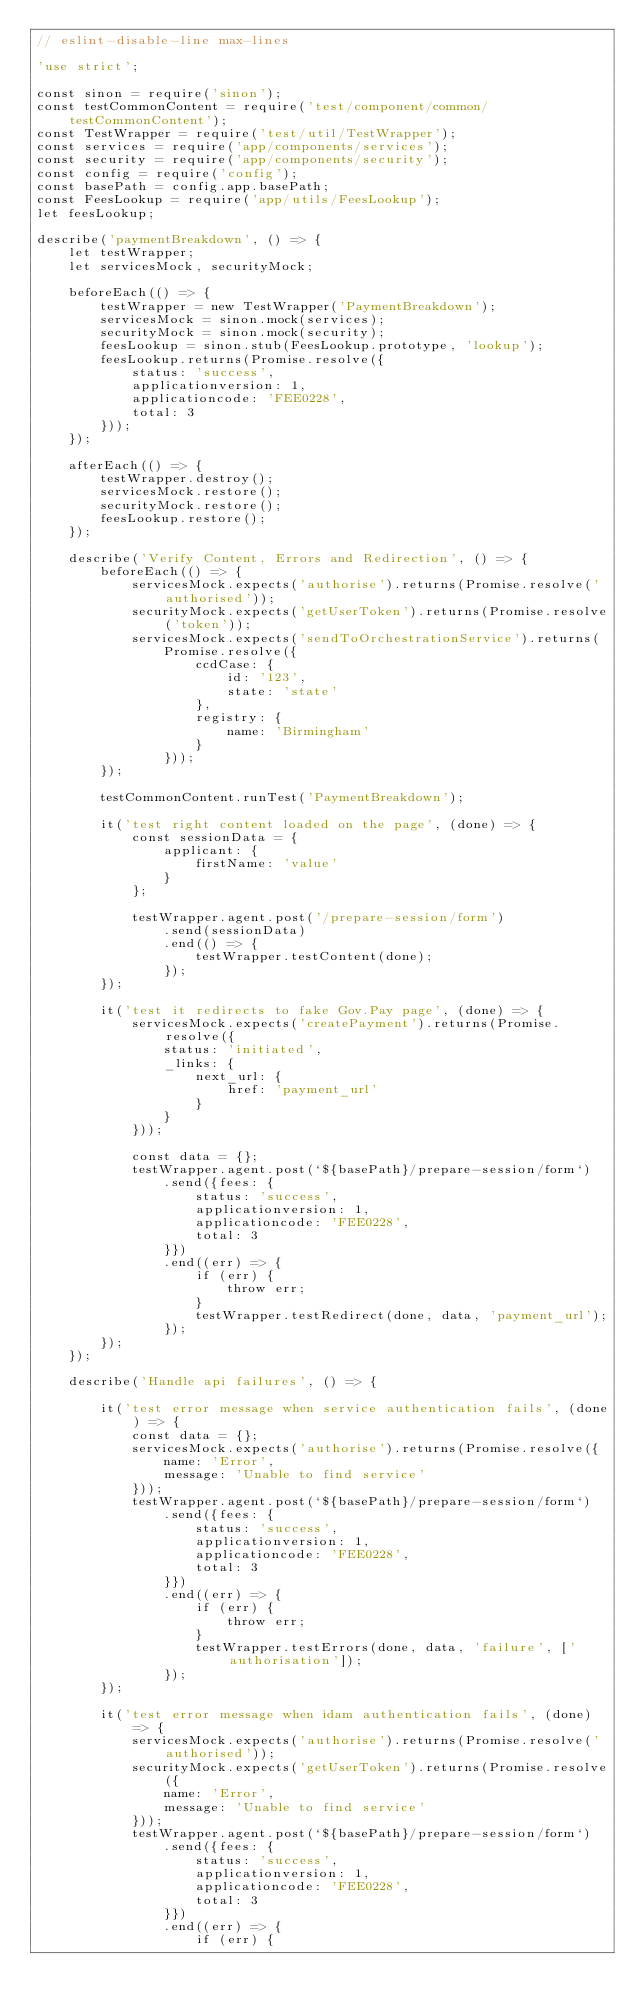<code> <loc_0><loc_0><loc_500><loc_500><_JavaScript_>// eslint-disable-line max-lines

'use strict';

const sinon = require('sinon');
const testCommonContent = require('test/component/common/testCommonContent');
const TestWrapper = require('test/util/TestWrapper');
const services = require('app/components/services');
const security = require('app/components/security');
const config = require('config');
const basePath = config.app.basePath;
const FeesLookup = require('app/utils/FeesLookup');
let feesLookup;

describe('paymentBreakdown', () => {
    let testWrapper;
    let servicesMock, securityMock;

    beforeEach(() => {
        testWrapper = new TestWrapper('PaymentBreakdown');
        servicesMock = sinon.mock(services);
        securityMock = sinon.mock(security);
        feesLookup = sinon.stub(FeesLookup.prototype, 'lookup');
        feesLookup.returns(Promise.resolve({
            status: 'success',
            applicationversion: 1,
            applicationcode: 'FEE0228',
            total: 3
        }));
    });

    afterEach(() => {
        testWrapper.destroy();
        servicesMock.restore();
        securityMock.restore();
        feesLookup.restore();
    });

    describe('Verify Content, Errors and Redirection', () => {
        beforeEach(() => {
            servicesMock.expects('authorise').returns(Promise.resolve('authorised'));
            securityMock.expects('getUserToken').returns(Promise.resolve('token'));
            servicesMock.expects('sendToOrchestrationService').returns(
                Promise.resolve({
                    ccdCase: {
                        id: '123',
                        state: 'state'
                    },
                    registry: {
                        name: 'Birmingham'
                    }
                }));
        });

        testCommonContent.runTest('PaymentBreakdown');

        it('test right content loaded on the page', (done) => {
            const sessionData = {
                applicant: {
                    firstName: 'value'
                }
            };

            testWrapper.agent.post('/prepare-session/form')
                .send(sessionData)
                .end(() => {
                    testWrapper.testContent(done);
                });
        });

        it('test it redirects to fake Gov.Pay page', (done) => {
            servicesMock.expects('createPayment').returns(Promise.resolve({
                status: 'initiated',
                _links: {
                    next_url: {
                        href: 'payment_url'
                    }
                }
            }));

            const data = {};
            testWrapper.agent.post(`${basePath}/prepare-session/form`)
                .send({fees: {
                    status: 'success',
                    applicationversion: 1,
                    applicationcode: 'FEE0228',
                    total: 3
                }})
                .end((err) => {
                    if (err) {
                        throw err;
                    }
                    testWrapper.testRedirect(done, data, 'payment_url');
                });
        });
    });

    describe('Handle api failures', () => {

        it('test error message when service authentication fails', (done) => {
            const data = {};
            servicesMock.expects('authorise').returns(Promise.resolve({
                name: 'Error',
                message: 'Unable to find service'
            }));
            testWrapper.agent.post(`${basePath}/prepare-session/form`)
                .send({fees: {
                    status: 'success',
                    applicationversion: 1,
                    applicationcode: 'FEE0228',
                    total: 3
                }})
                .end((err) => {
                    if (err) {
                        throw err;
                    }
                    testWrapper.testErrors(done, data, 'failure', ['authorisation']);
                });
        });

        it('test error message when idam authentication fails', (done) => {
            servicesMock.expects('authorise').returns(Promise.resolve('authorised'));
            securityMock.expects('getUserToken').returns(Promise.resolve({
                name: 'Error',
                message: 'Unable to find service'
            }));
            testWrapper.agent.post(`${basePath}/prepare-session/form`)
                .send({fees: {
                    status: 'success',
                    applicationversion: 1,
                    applicationcode: 'FEE0228',
                    total: 3
                }})
                .end((err) => {
                    if (err) {</code> 